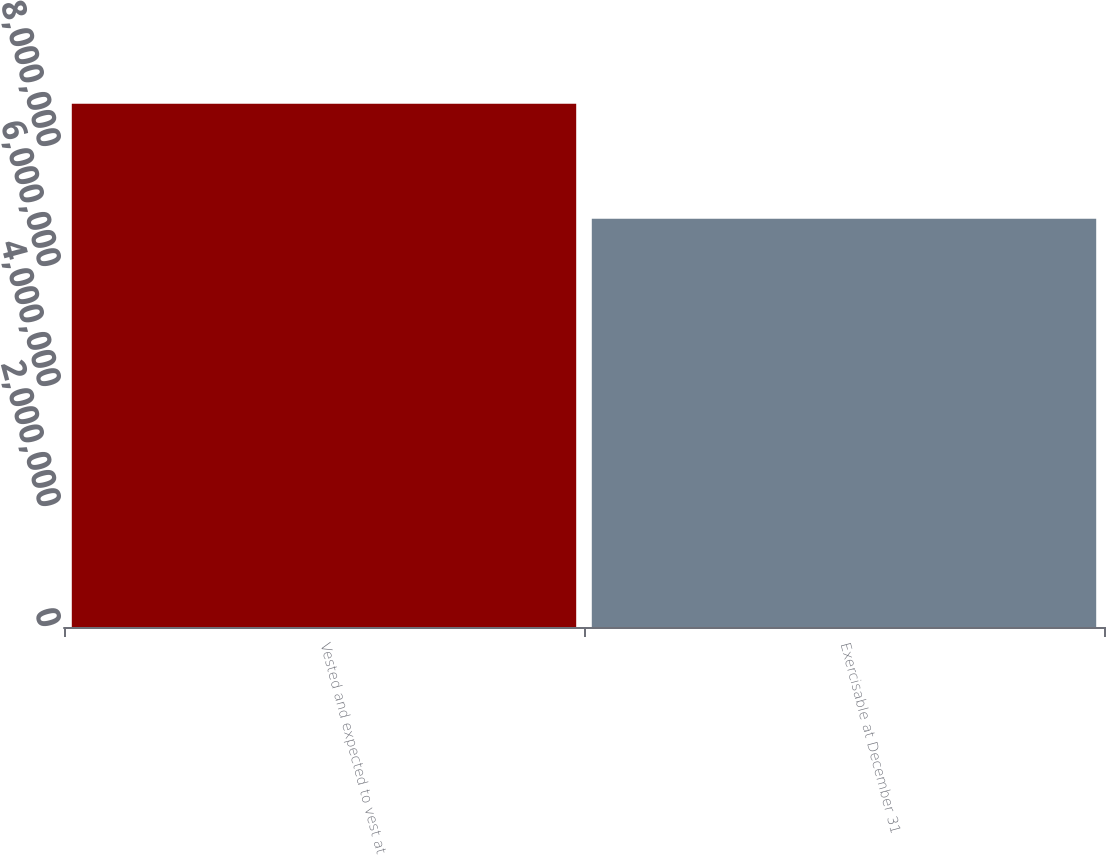Convert chart. <chart><loc_0><loc_0><loc_500><loc_500><bar_chart><fcel>Vested and expected to vest at<fcel>Exercisable at December 31<nl><fcel>8.71883e+06<fcel>6.80602e+06<nl></chart> 